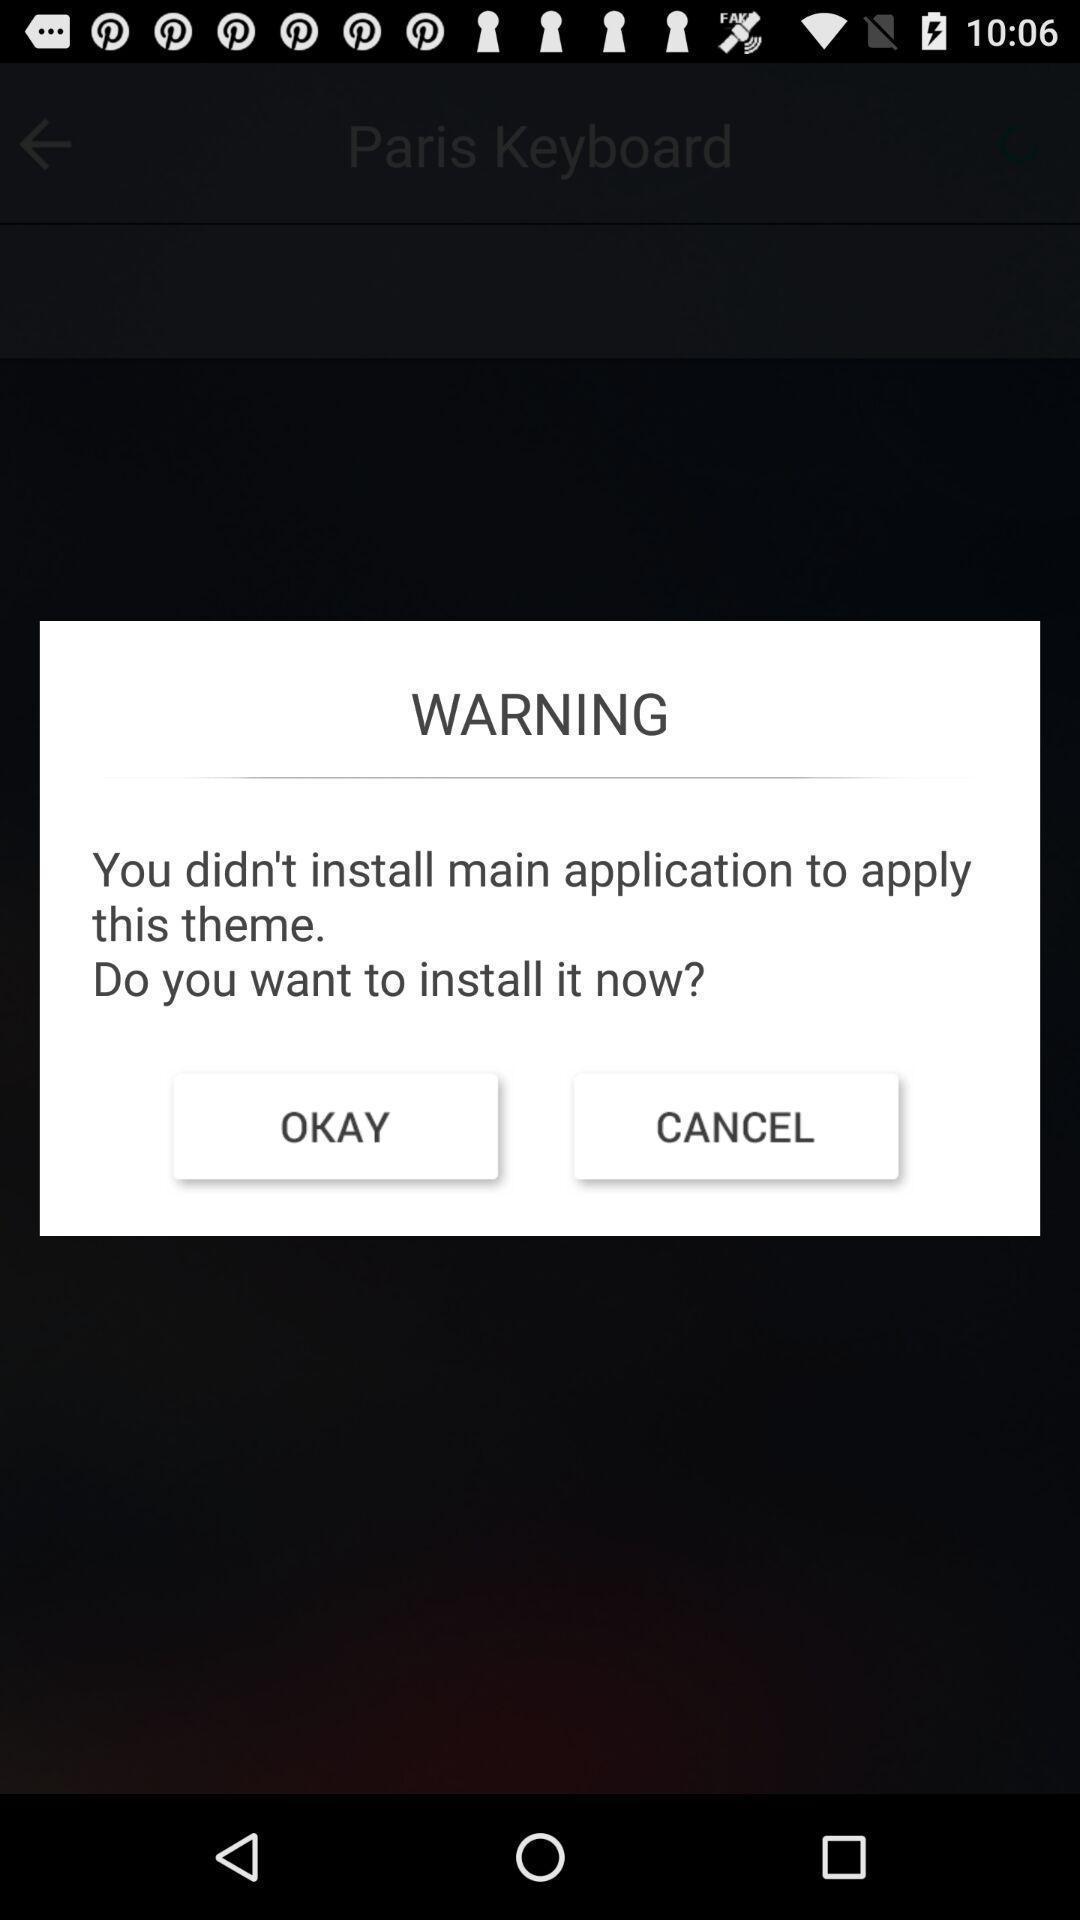Describe the content in this image. Warning text to install the application. 